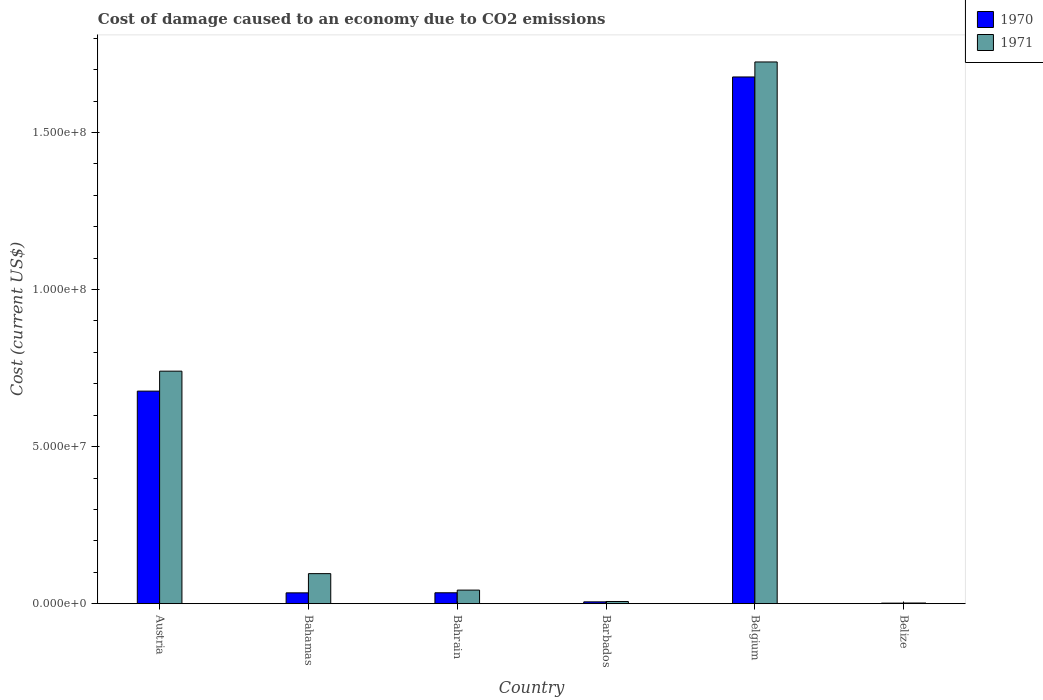How many different coloured bars are there?
Your answer should be compact. 2. Are the number of bars on each tick of the X-axis equal?
Your answer should be compact. Yes. How many bars are there on the 5th tick from the left?
Keep it short and to the point. 2. How many bars are there on the 4th tick from the right?
Provide a short and direct response. 2. What is the label of the 2nd group of bars from the left?
Your response must be concise. Bahamas. What is the cost of damage caused due to CO2 emissisons in 1970 in Barbados?
Keep it short and to the point. 5.73e+05. Across all countries, what is the maximum cost of damage caused due to CO2 emissisons in 1970?
Give a very brief answer. 1.68e+08. Across all countries, what is the minimum cost of damage caused due to CO2 emissisons in 1970?
Your response must be concise. 1.62e+05. In which country was the cost of damage caused due to CO2 emissisons in 1970 maximum?
Your answer should be compact. Belgium. In which country was the cost of damage caused due to CO2 emissisons in 1970 minimum?
Make the answer very short. Belize. What is the total cost of damage caused due to CO2 emissisons in 1970 in the graph?
Offer a very short reply. 2.43e+08. What is the difference between the cost of damage caused due to CO2 emissisons in 1970 in Austria and that in Belgium?
Give a very brief answer. -1.00e+08. What is the difference between the cost of damage caused due to CO2 emissisons in 1971 in Belize and the cost of damage caused due to CO2 emissisons in 1970 in Belgium?
Provide a short and direct response. -1.67e+08. What is the average cost of damage caused due to CO2 emissisons in 1971 per country?
Offer a terse response. 4.35e+07. What is the difference between the cost of damage caused due to CO2 emissisons of/in 1971 and cost of damage caused due to CO2 emissisons of/in 1970 in Austria?
Ensure brevity in your answer.  6.35e+06. In how many countries, is the cost of damage caused due to CO2 emissisons in 1971 greater than 60000000 US$?
Your answer should be very brief. 2. What is the ratio of the cost of damage caused due to CO2 emissisons in 1970 in Barbados to that in Belgium?
Your response must be concise. 0. Is the cost of damage caused due to CO2 emissisons in 1971 in Barbados less than that in Belize?
Your answer should be compact. No. What is the difference between the highest and the second highest cost of damage caused due to CO2 emissisons in 1970?
Ensure brevity in your answer.  6.42e+07. What is the difference between the highest and the lowest cost of damage caused due to CO2 emissisons in 1970?
Provide a succinct answer. 1.68e+08. Is the sum of the cost of damage caused due to CO2 emissisons in 1970 in Belgium and Belize greater than the maximum cost of damage caused due to CO2 emissisons in 1971 across all countries?
Your answer should be compact. No. What does the 1st bar from the left in Belize represents?
Your answer should be compact. 1970. What does the 2nd bar from the right in Barbados represents?
Your answer should be compact. 1970. Are all the bars in the graph horizontal?
Provide a short and direct response. No. Does the graph contain grids?
Offer a very short reply. No. Where does the legend appear in the graph?
Provide a short and direct response. Top right. What is the title of the graph?
Provide a short and direct response. Cost of damage caused to an economy due to CO2 emissions. Does "1973" appear as one of the legend labels in the graph?
Provide a succinct answer. No. What is the label or title of the X-axis?
Give a very brief answer. Country. What is the label or title of the Y-axis?
Keep it short and to the point. Cost (current US$). What is the Cost (current US$) of 1970 in Austria?
Your answer should be very brief. 6.77e+07. What is the Cost (current US$) in 1971 in Austria?
Your answer should be very brief. 7.40e+07. What is the Cost (current US$) in 1970 in Bahamas?
Give a very brief answer. 3.44e+06. What is the Cost (current US$) of 1971 in Bahamas?
Give a very brief answer. 9.55e+06. What is the Cost (current US$) in 1970 in Bahrain?
Make the answer very short. 3.46e+06. What is the Cost (current US$) in 1971 in Bahrain?
Ensure brevity in your answer.  4.31e+06. What is the Cost (current US$) in 1970 in Barbados?
Provide a short and direct response. 5.73e+05. What is the Cost (current US$) of 1971 in Barbados?
Make the answer very short. 6.87e+05. What is the Cost (current US$) in 1970 in Belgium?
Ensure brevity in your answer.  1.68e+08. What is the Cost (current US$) of 1971 in Belgium?
Your response must be concise. 1.72e+08. What is the Cost (current US$) of 1970 in Belize?
Your answer should be compact. 1.62e+05. What is the Cost (current US$) in 1971 in Belize?
Offer a very short reply. 2.03e+05. Across all countries, what is the maximum Cost (current US$) in 1970?
Your response must be concise. 1.68e+08. Across all countries, what is the maximum Cost (current US$) in 1971?
Your answer should be compact. 1.72e+08. Across all countries, what is the minimum Cost (current US$) in 1970?
Provide a short and direct response. 1.62e+05. Across all countries, what is the minimum Cost (current US$) in 1971?
Make the answer very short. 2.03e+05. What is the total Cost (current US$) in 1970 in the graph?
Your answer should be compact. 2.43e+08. What is the total Cost (current US$) of 1971 in the graph?
Give a very brief answer. 2.61e+08. What is the difference between the Cost (current US$) of 1970 in Austria and that in Bahamas?
Your response must be concise. 6.42e+07. What is the difference between the Cost (current US$) of 1971 in Austria and that in Bahamas?
Provide a succinct answer. 6.45e+07. What is the difference between the Cost (current US$) of 1970 in Austria and that in Bahrain?
Provide a short and direct response. 6.42e+07. What is the difference between the Cost (current US$) in 1971 in Austria and that in Bahrain?
Your answer should be compact. 6.97e+07. What is the difference between the Cost (current US$) of 1970 in Austria and that in Barbados?
Ensure brevity in your answer.  6.71e+07. What is the difference between the Cost (current US$) in 1971 in Austria and that in Barbados?
Your answer should be compact. 7.33e+07. What is the difference between the Cost (current US$) of 1970 in Austria and that in Belgium?
Keep it short and to the point. -1.00e+08. What is the difference between the Cost (current US$) in 1971 in Austria and that in Belgium?
Ensure brevity in your answer.  -9.84e+07. What is the difference between the Cost (current US$) of 1970 in Austria and that in Belize?
Give a very brief answer. 6.75e+07. What is the difference between the Cost (current US$) in 1971 in Austria and that in Belize?
Your answer should be compact. 7.38e+07. What is the difference between the Cost (current US$) in 1970 in Bahamas and that in Bahrain?
Offer a terse response. -2.45e+04. What is the difference between the Cost (current US$) of 1971 in Bahamas and that in Bahrain?
Provide a short and direct response. 5.24e+06. What is the difference between the Cost (current US$) of 1970 in Bahamas and that in Barbados?
Your answer should be compact. 2.86e+06. What is the difference between the Cost (current US$) in 1971 in Bahamas and that in Barbados?
Your response must be concise. 8.87e+06. What is the difference between the Cost (current US$) of 1970 in Bahamas and that in Belgium?
Your response must be concise. -1.64e+08. What is the difference between the Cost (current US$) of 1971 in Bahamas and that in Belgium?
Keep it short and to the point. -1.63e+08. What is the difference between the Cost (current US$) in 1970 in Bahamas and that in Belize?
Offer a terse response. 3.27e+06. What is the difference between the Cost (current US$) in 1971 in Bahamas and that in Belize?
Ensure brevity in your answer.  9.35e+06. What is the difference between the Cost (current US$) of 1970 in Bahrain and that in Barbados?
Your answer should be very brief. 2.89e+06. What is the difference between the Cost (current US$) in 1971 in Bahrain and that in Barbados?
Give a very brief answer. 3.63e+06. What is the difference between the Cost (current US$) in 1970 in Bahrain and that in Belgium?
Give a very brief answer. -1.64e+08. What is the difference between the Cost (current US$) of 1971 in Bahrain and that in Belgium?
Ensure brevity in your answer.  -1.68e+08. What is the difference between the Cost (current US$) of 1970 in Bahrain and that in Belize?
Your response must be concise. 3.30e+06. What is the difference between the Cost (current US$) of 1971 in Bahrain and that in Belize?
Your answer should be very brief. 4.11e+06. What is the difference between the Cost (current US$) of 1970 in Barbados and that in Belgium?
Ensure brevity in your answer.  -1.67e+08. What is the difference between the Cost (current US$) in 1971 in Barbados and that in Belgium?
Your answer should be very brief. -1.72e+08. What is the difference between the Cost (current US$) in 1970 in Barbados and that in Belize?
Provide a succinct answer. 4.11e+05. What is the difference between the Cost (current US$) of 1971 in Barbados and that in Belize?
Keep it short and to the point. 4.84e+05. What is the difference between the Cost (current US$) of 1970 in Belgium and that in Belize?
Ensure brevity in your answer.  1.68e+08. What is the difference between the Cost (current US$) in 1971 in Belgium and that in Belize?
Your response must be concise. 1.72e+08. What is the difference between the Cost (current US$) in 1970 in Austria and the Cost (current US$) in 1971 in Bahamas?
Give a very brief answer. 5.81e+07. What is the difference between the Cost (current US$) in 1970 in Austria and the Cost (current US$) in 1971 in Bahrain?
Make the answer very short. 6.34e+07. What is the difference between the Cost (current US$) in 1970 in Austria and the Cost (current US$) in 1971 in Barbados?
Provide a short and direct response. 6.70e+07. What is the difference between the Cost (current US$) of 1970 in Austria and the Cost (current US$) of 1971 in Belgium?
Your answer should be very brief. -1.05e+08. What is the difference between the Cost (current US$) of 1970 in Austria and the Cost (current US$) of 1971 in Belize?
Your answer should be compact. 6.75e+07. What is the difference between the Cost (current US$) in 1970 in Bahamas and the Cost (current US$) in 1971 in Bahrain?
Provide a short and direct response. -8.78e+05. What is the difference between the Cost (current US$) of 1970 in Bahamas and the Cost (current US$) of 1971 in Barbados?
Give a very brief answer. 2.75e+06. What is the difference between the Cost (current US$) in 1970 in Bahamas and the Cost (current US$) in 1971 in Belgium?
Ensure brevity in your answer.  -1.69e+08. What is the difference between the Cost (current US$) in 1970 in Bahamas and the Cost (current US$) in 1971 in Belize?
Your response must be concise. 3.23e+06. What is the difference between the Cost (current US$) of 1970 in Bahrain and the Cost (current US$) of 1971 in Barbados?
Make the answer very short. 2.77e+06. What is the difference between the Cost (current US$) in 1970 in Bahrain and the Cost (current US$) in 1971 in Belgium?
Your answer should be compact. -1.69e+08. What is the difference between the Cost (current US$) of 1970 in Bahrain and the Cost (current US$) of 1971 in Belize?
Your answer should be compact. 3.26e+06. What is the difference between the Cost (current US$) of 1970 in Barbados and the Cost (current US$) of 1971 in Belgium?
Make the answer very short. -1.72e+08. What is the difference between the Cost (current US$) of 1970 in Barbados and the Cost (current US$) of 1971 in Belize?
Provide a succinct answer. 3.70e+05. What is the difference between the Cost (current US$) of 1970 in Belgium and the Cost (current US$) of 1971 in Belize?
Your answer should be very brief. 1.67e+08. What is the average Cost (current US$) of 1970 per country?
Give a very brief answer. 4.05e+07. What is the average Cost (current US$) of 1971 per country?
Your response must be concise. 4.35e+07. What is the difference between the Cost (current US$) of 1970 and Cost (current US$) of 1971 in Austria?
Provide a short and direct response. -6.35e+06. What is the difference between the Cost (current US$) in 1970 and Cost (current US$) in 1971 in Bahamas?
Your response must be concise. -6.12e+06. What is the difference between the Cost (current US$) in 1970 and Cost (current US$) in 1971 in Bahrain?
Your answer should be very brief. -8.53e+05. What is the difference between the Cost (current US$) in 1970 and Cost (current US$) in 1971 in Barbados?
Your answer should be very brief. -1.14e+05. What is the difference between the Cost (current US$) in 1970 and Cost (current US$) in 1971 in Belgium?
Make the answer very short. -4.78e+06. What is the difference between the Cost (current US$) of 1970 and Cost (current US$) of 1971 in Belize?
Give a very brief answer. -4.14e+04. What is the ratio of the Cost (current US$) of 1970 in Austria to that in Bahamas?
Your answer should be compact. 19.69. What is the ratio of the Cost (current US$) in 1971 in Austria to that in Bahamas?
Provide a succinct answer. 7.75. What is the ratio of the Cost (current US$) of 1970 in Austria to that in Bahrain?
Make the answer very short. 19.55. What is the ratio of the Cost (current US$) in 1971 in Austria to that in Bahrain?
Give a very brief answer. 17.16. What is the ratio of the Cost (current US$) in 1970 in Austria to that in Barbados?
Offer a very short reply. 118.15. What is the ratio of the Cost (current US$) in 1971 in Austria to that in Barbados?
Keep it short and to the point. 107.75. What is the ratio of the Cost (current US$) in 1970 in Austria to that in Belgium?
Make the answer very short. 0.4. What is the ratio of the Cost (current US$) of 1971 in Austria to that in Belgium?
Make the answer very short. 0.43. What is the ratio of the Cost (current US$) in 1970 in Austria to that in Belize?
Ensure brevity in your answer.  418.91. What is the ratio of the Cost (current US$) of 1971 in Austria to that in Belize?
Give a very brief answer. 364.69. What is the ratio of the Cost (current US$) in 1970 in Bahamas to that in Bahrain?
Provide a succinct answer. 0.99. What is the ratio of the Cost (current US$) of 1971 in Bahamas to that in Bahrain?
Offer a terse response. 2.21. What is the ratio of the Cost (current US$) in 1971 in Bahamas to that in Barbados?
Your answer should be very brief. 13.91. What is the ratio of the Cost (current US$) of 1970 in Bahamas to that in Belgium?
Your answer should be very brief. 0.02. What is the ratio of the Cost (current US$) in 1971 in Bahamas to that in Belgium?
Your answer should be very brief. 0.06. What is the ratio of the Cost (current US$) of 1970 in Bahamas to that in Belize?
Offer a very short reply. 21.27. What is the ratio of the Cost (current US$) of 1971 in Bahamas to that in Belize?
Keep it short and to the point. 47.08. What is the ratio of the Cost (current US$) of 1970 in Bahrain to that in Barbados?
Offer a very short reply. 6.04. What is the ratio of the Cost (current US$) in 1971 in Bahrain to that in Barbados?
Ensure brevity in your answer.  6.28. What is the ratio of the Cost (current US$) of 1970 in Bahrain to that in Belgium?
Offer a very short reply. 0.02. What is the ratio of the Cost (current US$) of 1971 in Bahrain to that in Belgium?
Your answer should be compact. 0.03. What is the ratio of the Cost (current US$) of 1970 in Bahrain to that in Belize?
Make the answer very short. 21.42. What is the ratio of the Cost (current US$) of 1971 in Bahrain to that in Belize?
Give a very brief answer. 21.26. What is the ratio of the Cost (current US$) of 1970 in Barbados to that in Belgium?
Keep it short and to the point. 0. What is the ratio of the Cost (current US$) of 1971 in Barbados to that in Belgium?
Your answer should be compact. 0. What is the ratio of the Cost (current US$) in 1970 in Barbados to that in Belize?
Make the answer very short. 3.55. What is the ratio of the Cost (current US$) in 1971 in Barbados to that in Belize?
Provide a succinct answer. 3.38. What is the ratio of the Cost (current US$) in 1970 in Belgium to that in Belize?
Offer a very short reply. 1038.09. What is the ratio of the Cost (current US$) of 1971 in Belgium to that in Belize?
Offer a terse response. 849.77. What is the difference between the highest and the second highest Cost (current US$) of 1970?
Offer a very short reply. 1.00e+08. What is the difference between the highest and the second highest Cost (current US$) of 1971?
Keep it short and to the point. 9.84e+07. What is the difference between the highest and the lowest Cost (current US$) in 1970?
Your response must be concise. 1.68e+08. What is the difference between the highest and the lowest Cost (current US$) in 1971?
Your answer should be very brief. 1.72e+08. 